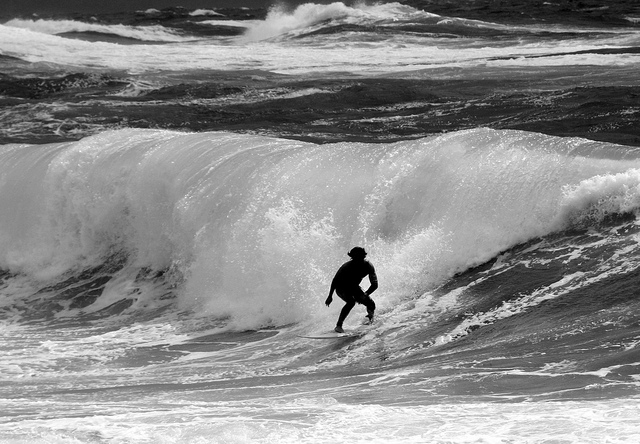Is the person wearing a hat? Yes, the person is wearing what seems to be a protective helmet, which is a wise choice to safeguard against potential head injuries while surfing these powerful waves. 